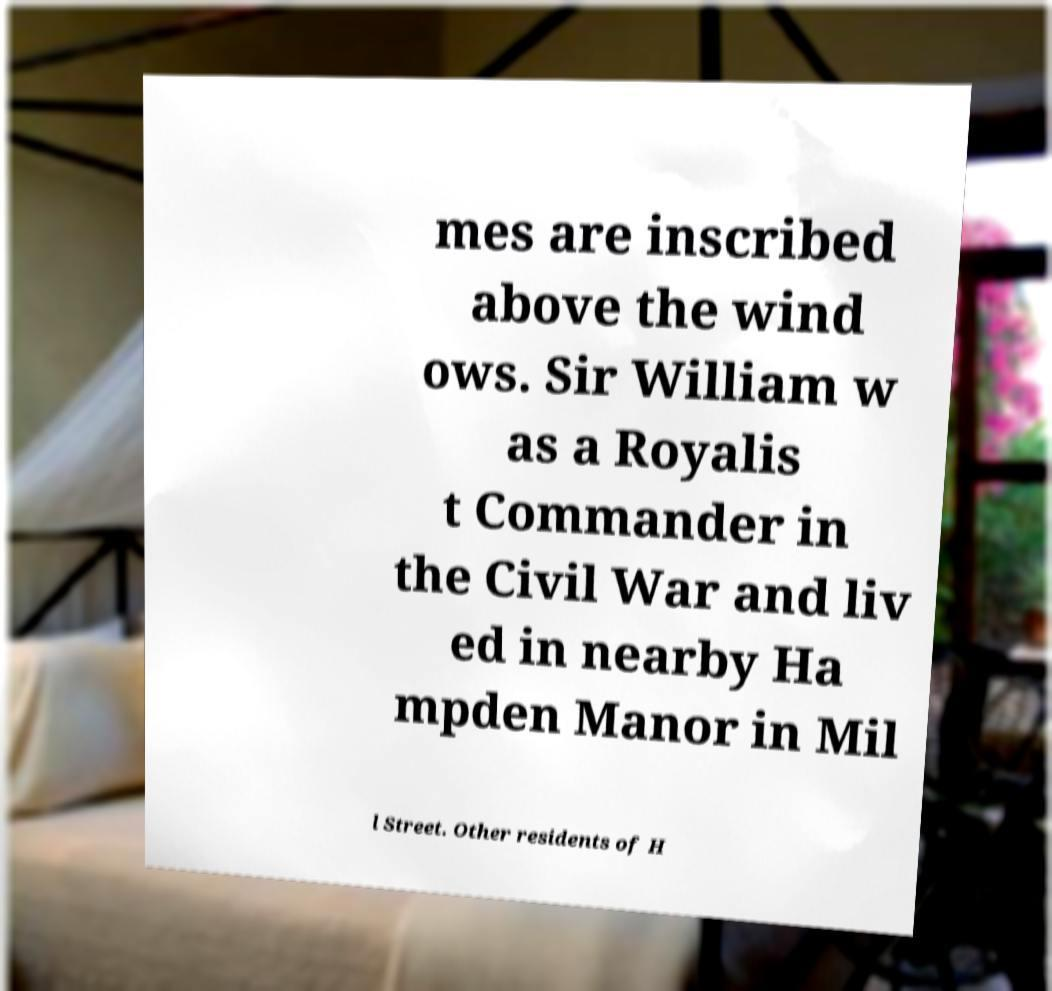I need the written content from this picture converted into text. Can you do that? mes are inscribed above the wind ows. Sir William w as a Royalis t Commander in the Civil War and liv ed in nearby Ha mpden Manor in Mil l Street. Other residents of H 